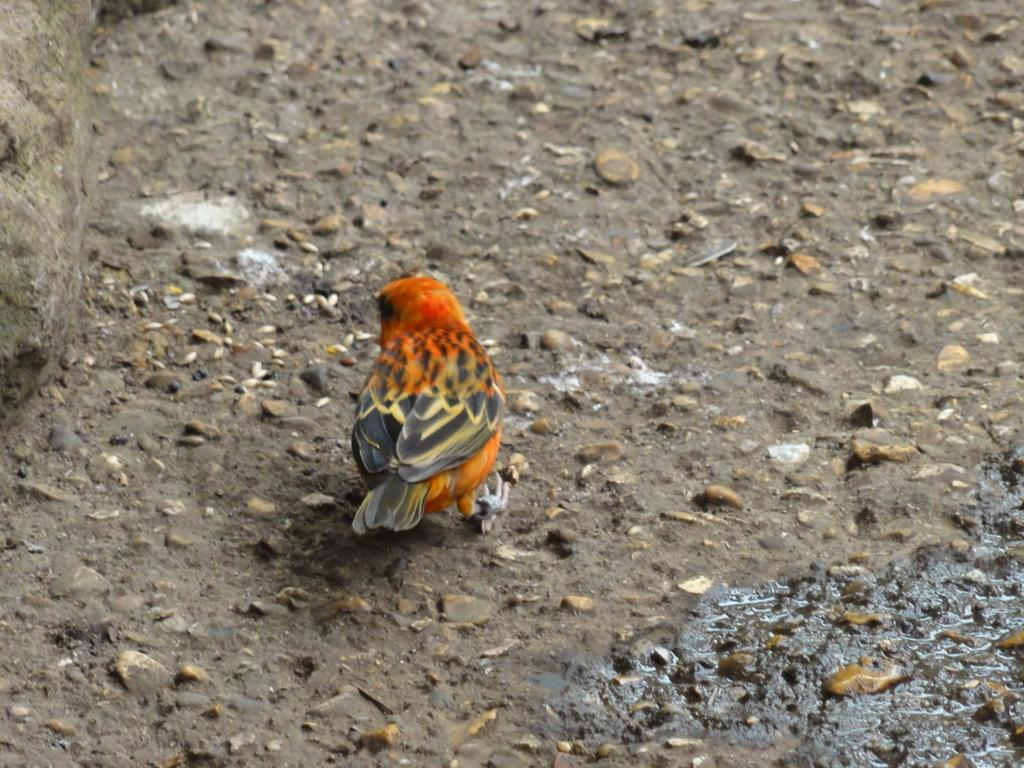What type of animal is in the image? There is a bird in the image. Where is the bird located in the image? The bird is standing on the floor. How is the bird positioned in the image? The bird is in the center of the image. What else can be seen on the floor in the image? There are dry leaves on the floor. What type of stone is the bird holding in its beak in the image? There is no stone present in the image, and the bird is not holding anything in its beak. 